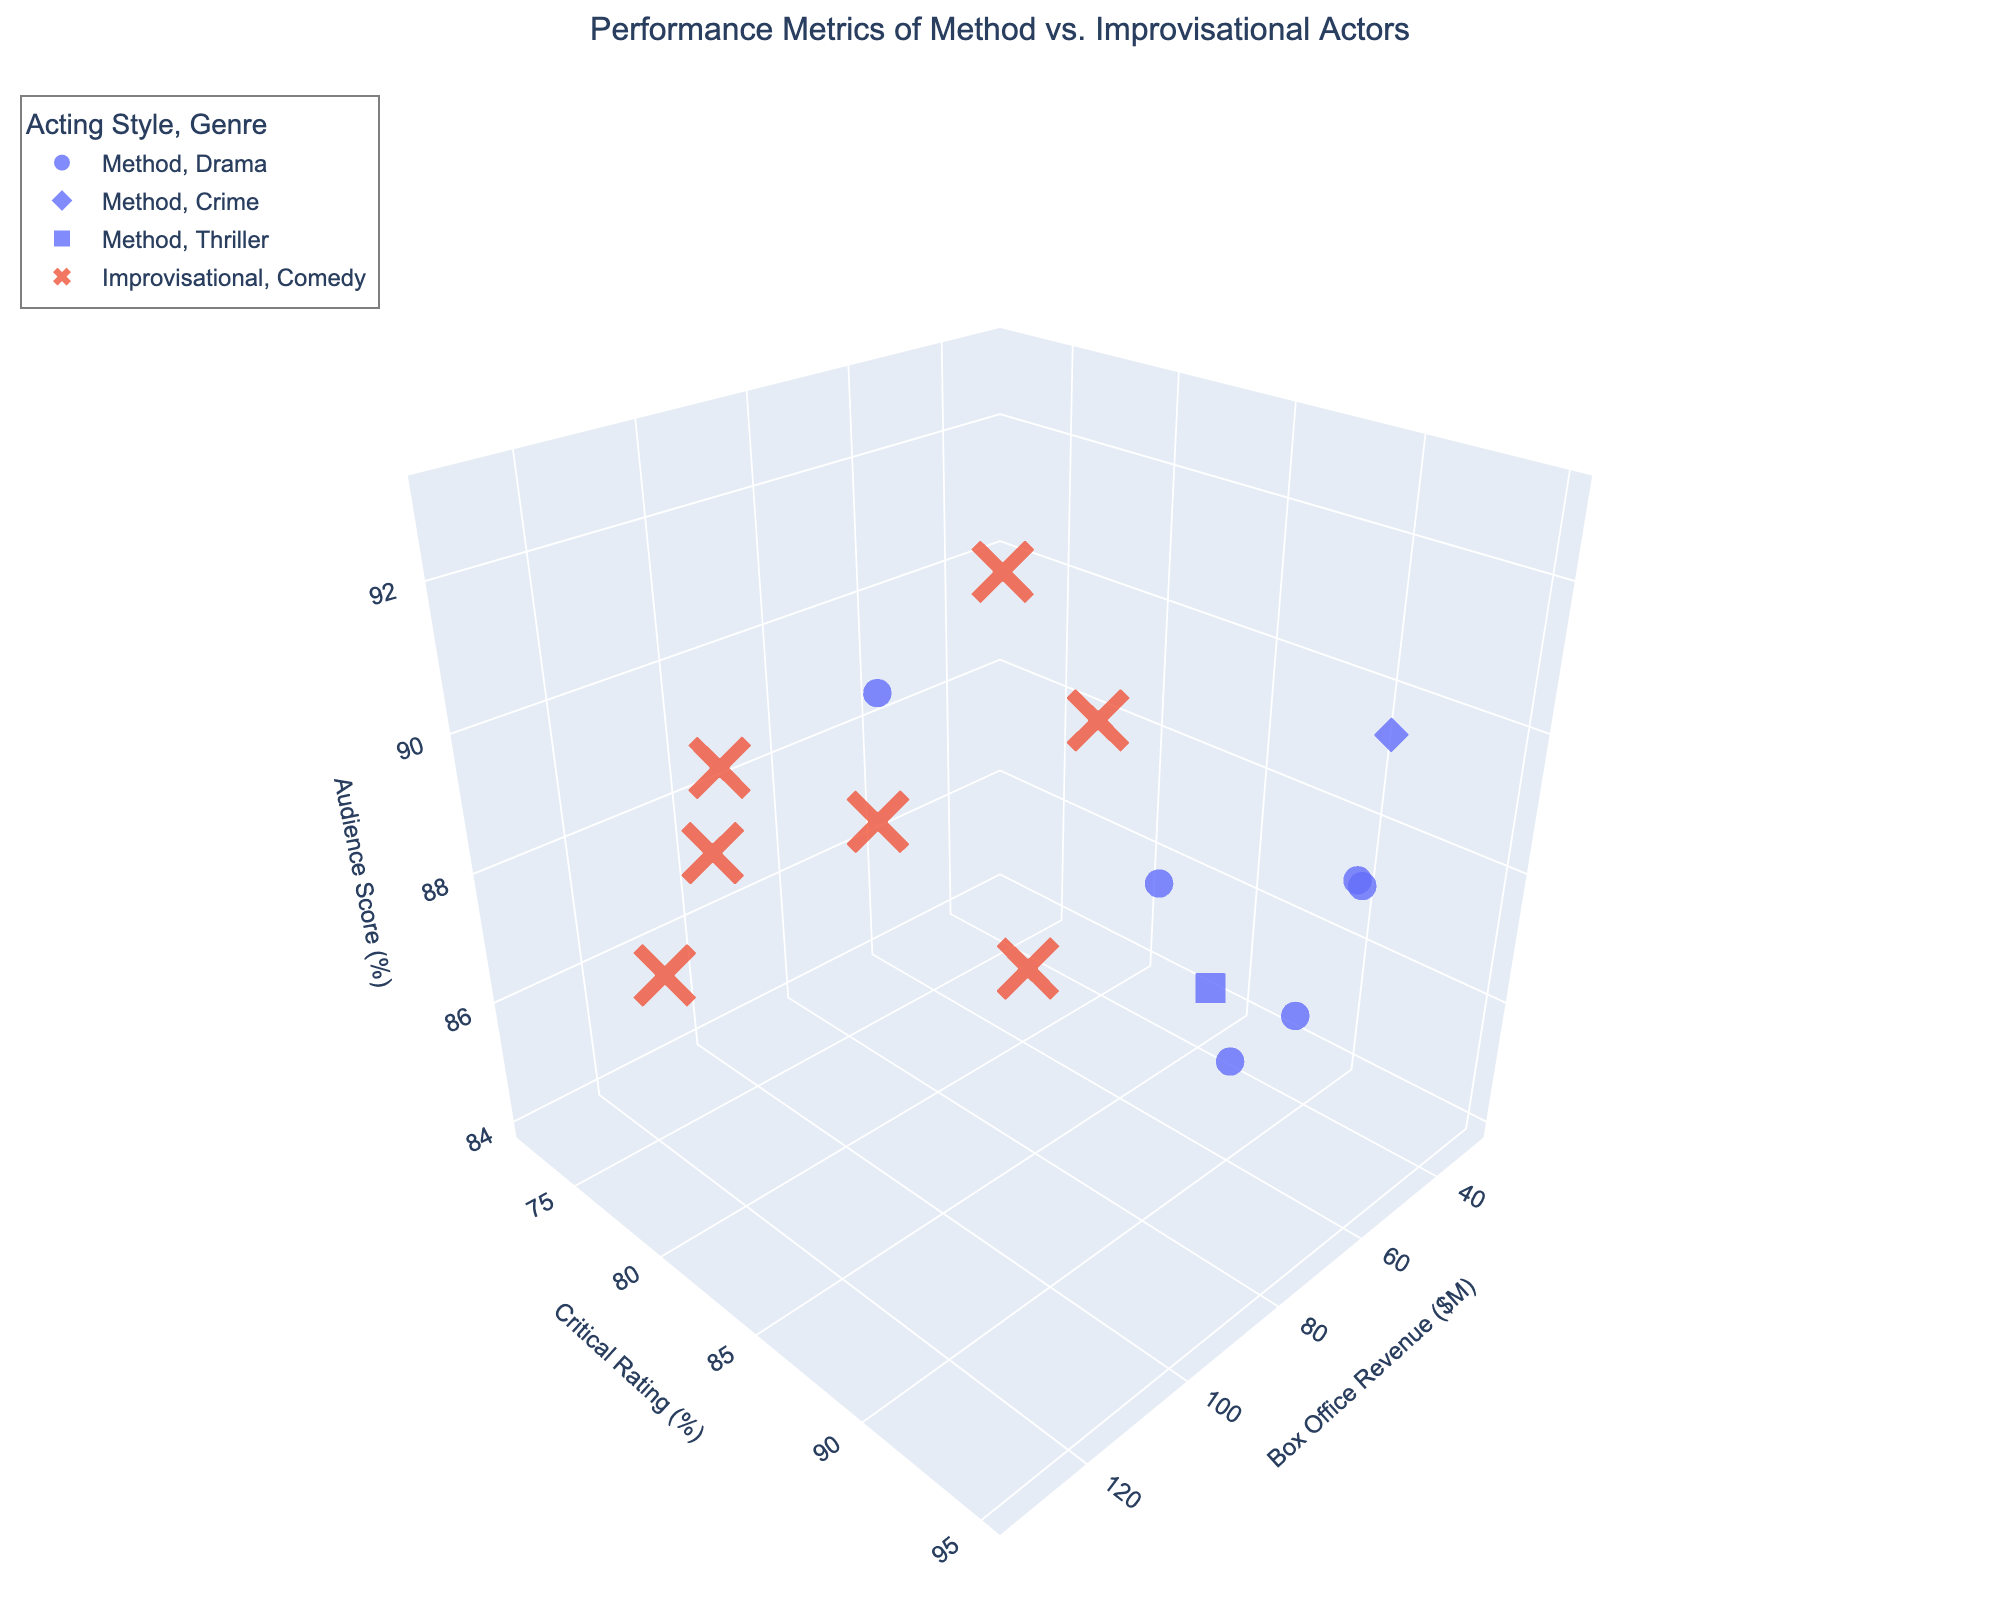How many different genres are represented in the plot? The genres are represented by different symbols in the plot. By counting these, we can see there are Drama, Crime, Thriller, and Comedy genres.
Answer: 4 Which actor has the highest box office revenue? By observing the x-axis (Box Office Revenue) values for all data points, the highest value corresponds to Leonardo DiCaprio in the Drama genre with 132.5 million dollars.
Answer: Leonardo DiCaprio Is there a trend in audience scores for improvisational actors across different genres? By examining the z-axis (Audience Score) for the improvisational actors (which are marked in a distinct color), we can see that their scores generally cluster in the higher range, especially for Comedy, suggesting that improvisational actors receive high audience scores across different films.
Answer: Yes, generally high Compare the average critical ratings between method actors and improvisational actors. The average critical rating can be calculated by summing up the ratings for each acting style and dividing by their respective number of actors. Method actors: (92 + 89 + 95 + 88 + 90 + 91 + 93 + 87) / 8 = 90.62. Improvisational actors: (83 + 75 + 72 + 80 + 78 + 85 + 74) / 7 = 78.14. 90.62 - 78.14 = 12.48.
Answer: Method actors have an average rating of 90.62, which is 12.48 higher than the improvisational actors' average of 78.14 Which genre has the highest combined box office revenue? Summing up the box office revenues for each genre: Drama (45.5 + 38.2 + 132.5 + 96.4 + 42.7) = 355.3, Comedy (78.4 + 102.3 + 95.6 + 58.9 + 83.2 + 68.1 + 112.8) = 599.3, Crime (62.7), and Thriller (55.3). Comedy has the highest combined revenue.
Answer: Comedy How do the box office revenues of method actors compare to improvisational actors in the Comedy genre? By examining the Comedy genre and separating the acting styles, we see that all the box office revenues in the Comedy genre belong to improvisational actors, with values 78.4, 102.3, 95.6, 58.9, 83.2, 68.1, and 112.8 million dollars. Method actors are not listed in Comedy since no points fall under this genre.
Answer: Improvisational actors dominate Which acting style shows a wider range in critical ratings? By looking at the y-axis (Critical Rating) values, method actors have ratings ranging from 87 to 95 (a range of 8), while improvisational actors range from 72 to 85 (a range of 13). Improvisational actors have a wider range of critical ratings.
Answer: Improvisational actors Do method actors or improvisational actors have higher audience scores on average? Calculate the average audience scores for each style: Method actors: (88 + 85 + 91 + 86 + 87 + 93 + 90 + 84) / 8 = 88. De Improvisational actors: (92 + 89 + 87 + 85 + 88 + 90 + 86) / 7 = 88.14. The averages indicate improvisational actors score slightly higher.
Answer: Improvisational actors have a higher average score Is there a significant difference in the box office revenue of method actors in the Drama genre versus Improvisational actors in Comedy? Summing the box office revenues: Method actors in Drama: 45.5 + 38.2 + 132.5 + 96.4 + 42.7 = 355.3. Improvisational actors in Comedy: 78.4 + 102.3 + 95.6 + 58.9 + 83.2 + 68.1 + 112.8 = 599.3. Improvisational actors in Comedy generate significantly higher revenue.
Answer: Yes, improvisational actors in Comedy have higher revenue Between Method actors and Improvisational actors, who has the highest box office revenue in the Drama genre? For Drama, looking at the Method actors’ box office revenues: 45.5, 38.2, 132.5, 96.4, 42.7. Leonardo DiCaprio (132.5) from the Method actors has the highest revenue.
Answer: Method actors 